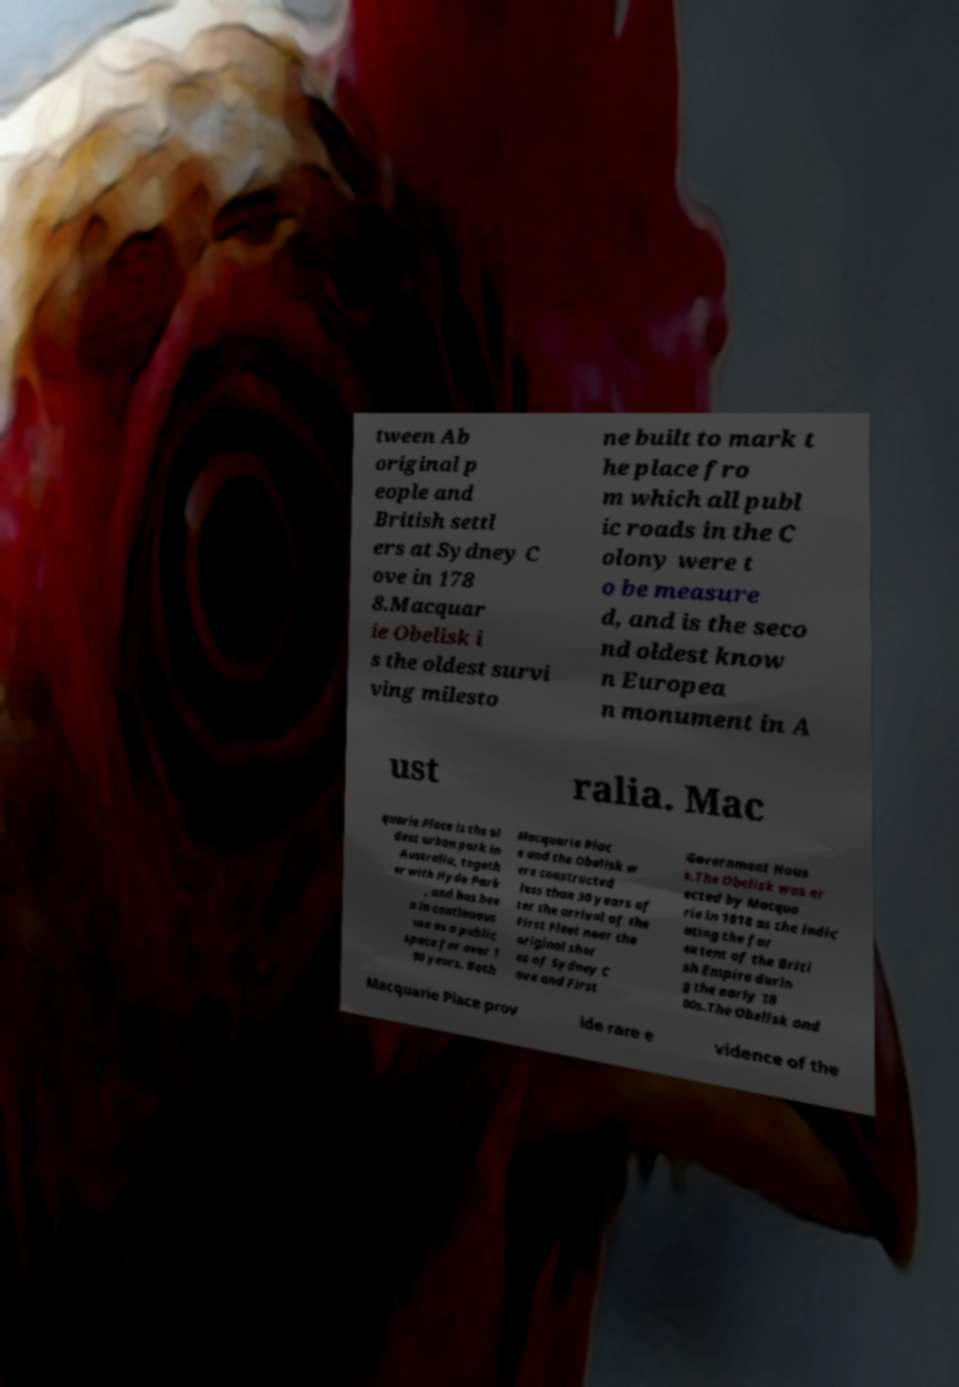There's text embedded in this image that I need extracted. Can you transcribe it verbatim? tween Ab original p eople and British settl ers at Sydney C ove in 178 8.Macquar ie Obelisk i s the oldest survi ving milesto ne built to mark t he place fro m which all publ ic roads in the C olony were t o be measure d, and is the seco nd oldest know n Europea n monument in A ust ralia. Mac quarie Place is the ol dest urban park in Australia, togeth er with Hyde Park , and has bee n in continuous use as a public space for over 1 90 years. Both Macquarie Plac e and the Obelisk w ere constructed less than 30 years af ter the arrival of the First Fleet near the original shor es of Sydney C ove and First Government Hous e.The Obelisk was er ected by Macqua rie in 1818 as the indic ating the far extent of the Briti sh Empire durin g the early 18 00s.The Obelisk and Macquarie Place prov ide rare e vidence of the 